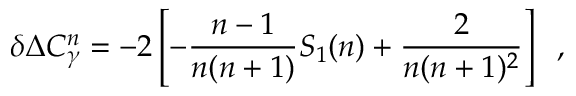<formula> <loc_0><loc_0><loc_500><loc_500>\delta \Delta C _ { \gamma } ^ { n } = - 2 \left [ - \frac { n - 1 } { n ( n + 1 ) } S _ { 1 } ( n ) + \frac { 2 } { n ( n + 1 ) ^ { 2 } } \right ] \, ,</formula> 